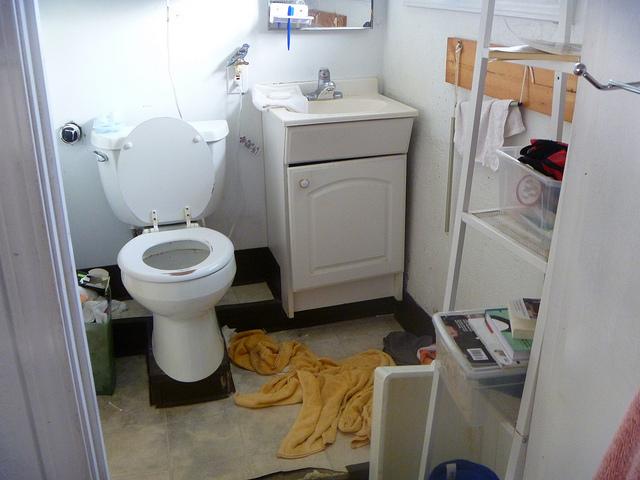Who is lying on the floor?
Keep it brief. Towels. Is there a cat?
Answer briefly. No. What is the bathroom for?
Keep it brief. Bathing. Is the bathroom dirty?
Answer briefly. Yes. What room is this?
Quick response, please. Bathroom. 